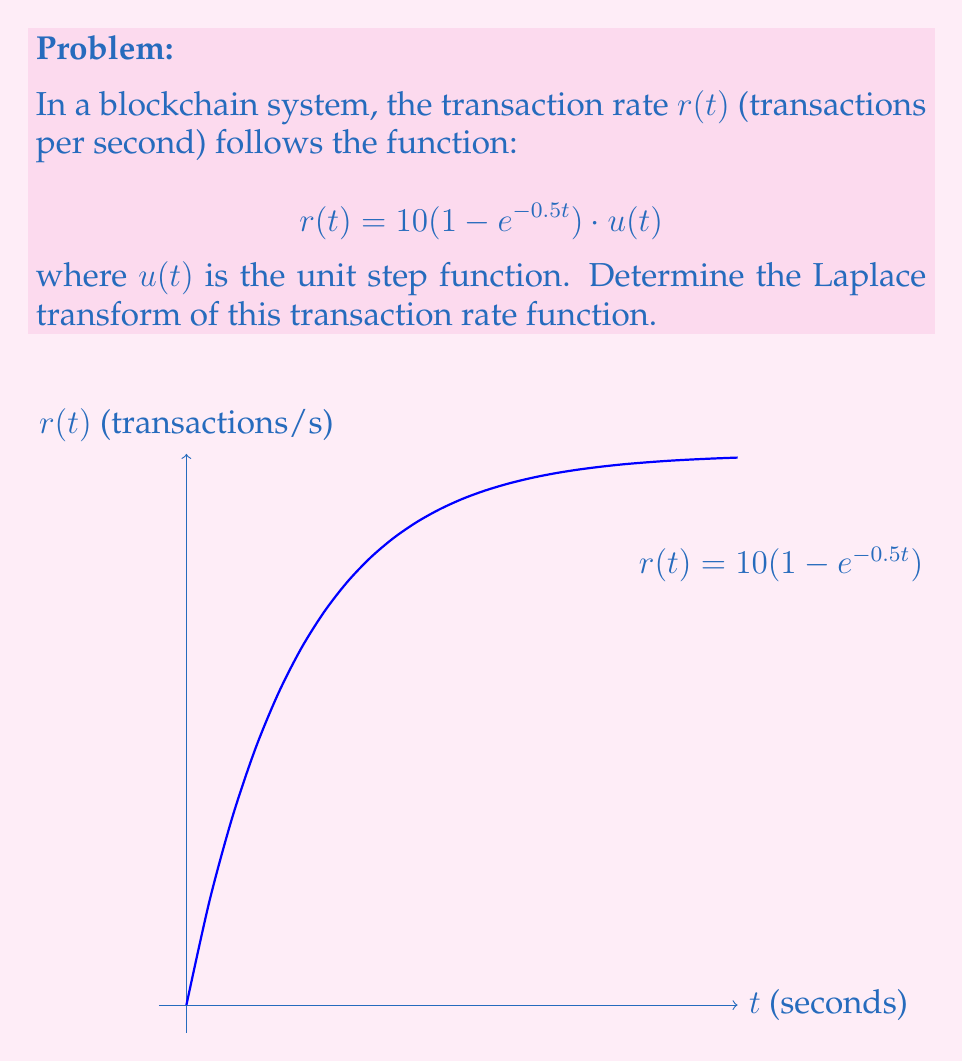Help me with this question. Let's approach this step-by-step:

1) The Laplace transform of a function $f(t)$ is defined as:

   $$\mathcal{L}\{f(t)\} = F(s) = \int_0^{\infty} f(t)e^{-st} dt$$

2) Our function is:

   $$r(t) = 10(1 - e^{-0.5t}) \cdot u(t)$$

3) The unit step function $u(t)$ allows us to start the integral from 0 to $\infty$:

   $$\mathcal{L}\{r(t)\} = \int_0^{\infty} 10(1 - e^{-0.5t})e^{-st} dt$$

4) Distribute the constant:

   $$= 10\int_0^{\infty} (e^{-st} - e^{-(s+0.5)t}) dt$$

5) Integrate each term separately:

   $$= 10 \left[ -\frac{1}{s}e^{-st} + \frac{1}{s+0.5}e^{-(s+0.5)t} \right]_0^{\infty}$$

6) Evaluate the limits:

   $$= 10 \left[ (0 + \frac{1}{s}) - (0 + \frac{1}{s+0.5}) \right]$$

7) Simplify:

   $$= 10 \left( \frac{1}{s} - \frac{1}{s+0.5} \right)$$

8) Find a common denominator:

   $$= 10 \left( \frac{s+0.5}{s(s+0.5)} - \frac{s}{s(s+0.5)} \right)$$

9) Simplify the numerator:

   $$= 10 \left( \frac{0.5}{s(s+0.5)} \right)$$

10) This is our final result for the Laplace transform of $r(t)$.
Answer: $$\mathcal{L}\{r(t)\} = \frac{5}{s(s+0.5)}$$ 